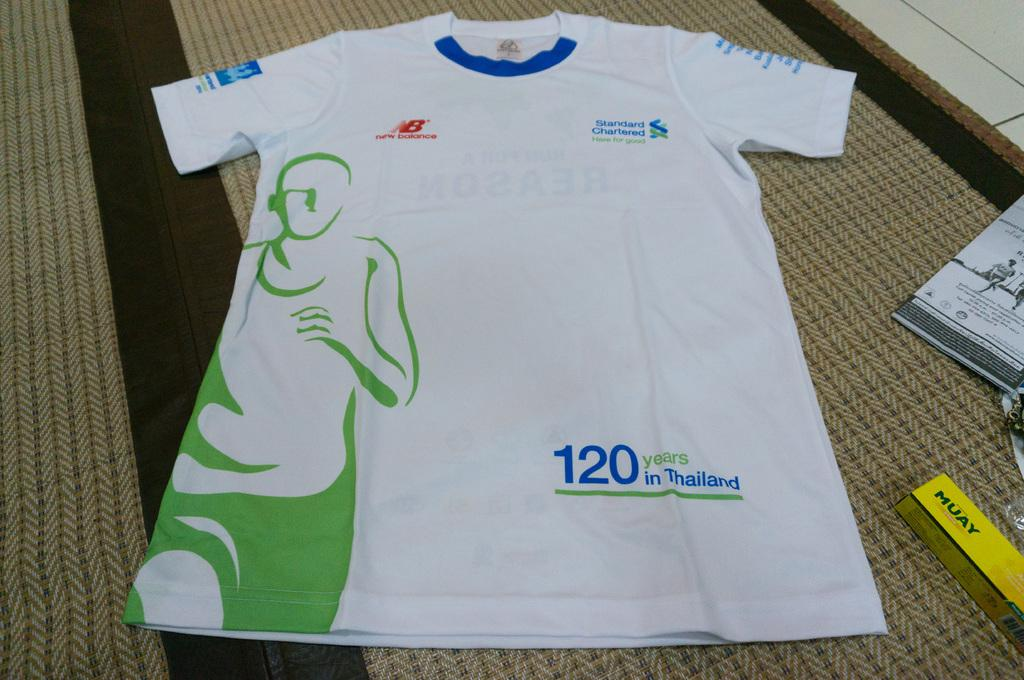<image>
Relay a brief, clear account of the picture shown. The white shirt says, '120 years in Thailand', and it has the image of a runner on it. 